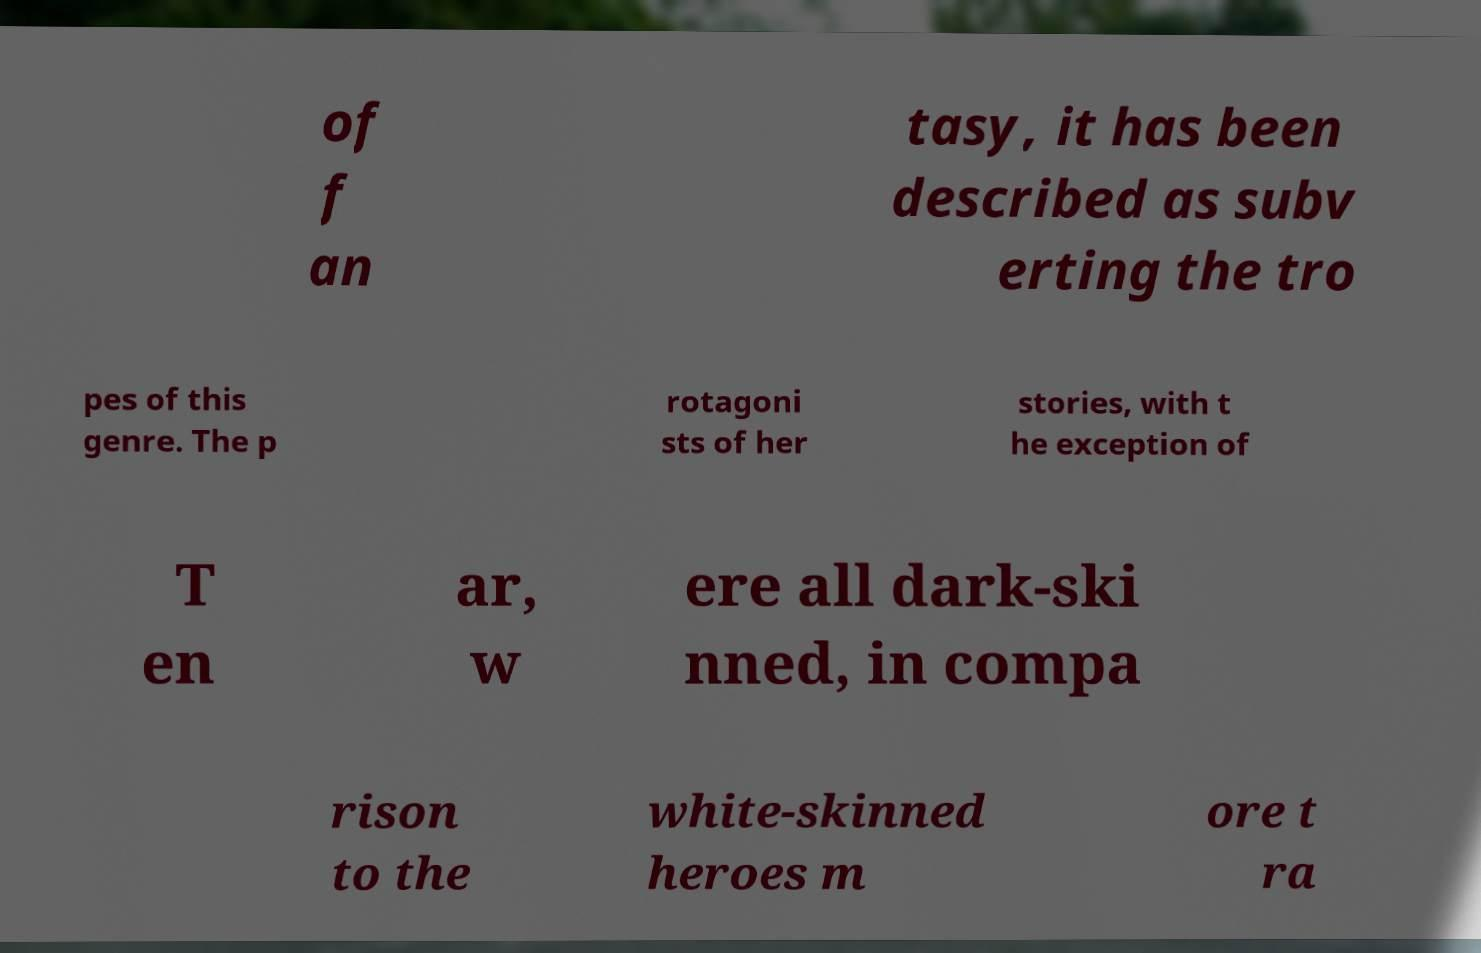Could you assist in decoding the text presented in this image and type it out clearly? of f an tasy, it has been described as subv erting the tro pes of this genre. The p rotagoni sts of her stories, with t he exception of T en ar, w ere all dark-ski nned, in compa rison to the white-skinned heroes m ore t ra 